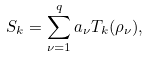Convert formula to latex. <formula><loc_0><loc_0><loc_500><loc_500>S _ { k } = \sum _ { \nu = 1 } ^ { q } a _ { \nu } T _ { k } ( \rho _ { \nu } ) ,</formula> 